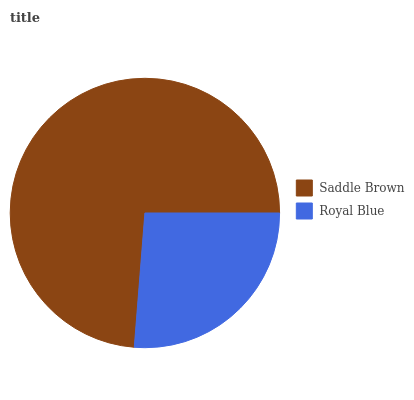Is Royal Blue the minimum?
Answer yes or no. Yes. Is Saddle Brown the maximum?
Answer yes or no. Yes. Is Royal Blue the maximum?
Answer yes or no. No. Is Saddle Brown greater than Royal Blue?
Answer yes or no. Yes. Is Royal Blue less than Saddle Brown?
Answer yes or no. Yes. Is Royal Blue greater than Saddle Brown?
Answer yes or no. No. Is Saddle Brown less than Royal Blue?
Answer yes or no. No. Is Saddle Brown the high median?
Answer yes or no. Yes. Is Royal Blue the low median?
Answer yes or no. Yes. Is Royal Blue the high median?
Answer yes or no. No. Is Saddle Brown the low median?
Answer yes or no. No. 